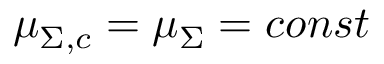Convert formula to latex. <formula><loc_0><loc_0><loc_500><loc_500>\mu _ { \Sigma , c } = \mu _ { \Sigma } = c o n s t</formula> 